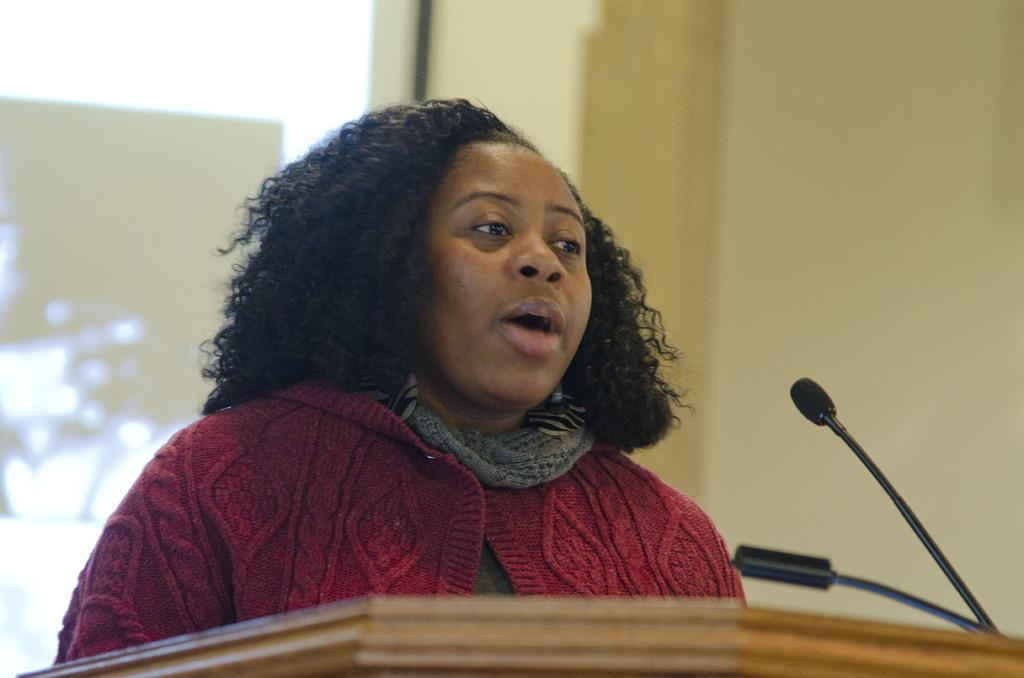Who is the main subject in the image? There is a woman in the image. What is the woman doing in the image? The woman is standing near a speaker stand. What object is present in the image that is typically used for amplifying sound? There is a microphone in the image. How many spiders are crawling on the microphone in the image? There are no spiders present in the image, and therefore no such activity can be observed. 